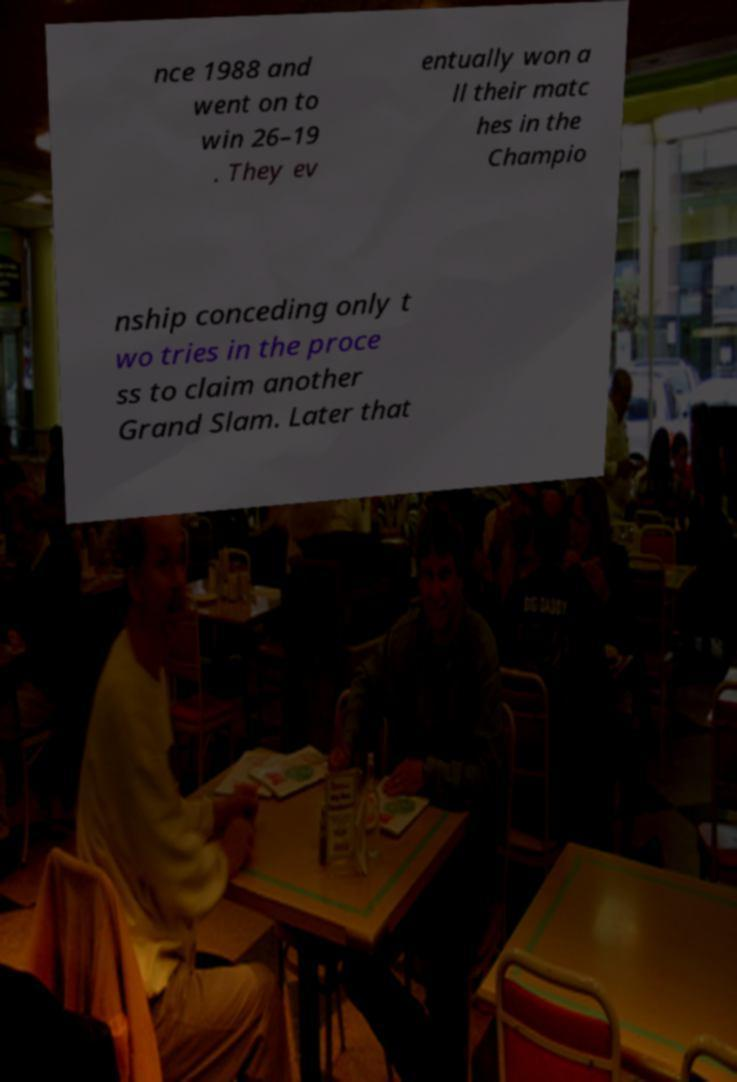Could you assist in decoding the text presented in this image and type it out clearly? nce 1988 and went on to win 26–19 . They ev entually won a ll their matc hes in the Champio nship conceding only t wo tries in the proce ss to claim another Grand Slam. Later that 